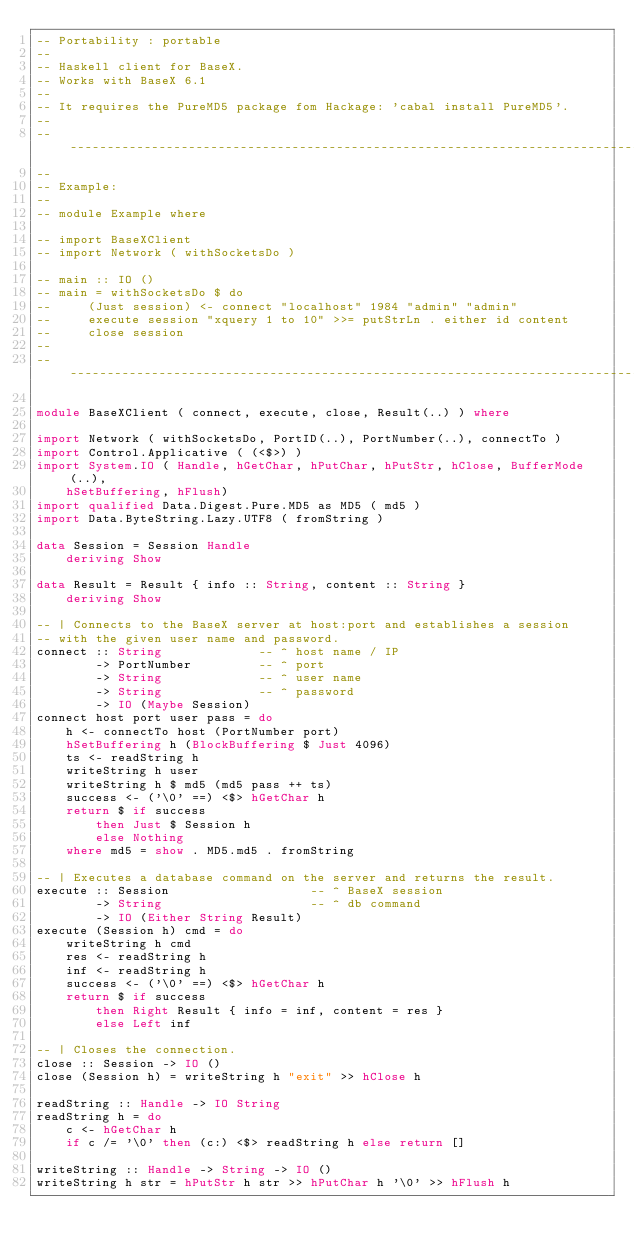Convert code to text. <code><loc_0><loc_0><loc_500><loc_500><_Haskell_>-- Portability : portable
--
-- Haskell client for BaseX.
-- Works with BaseX 6.1
--
-- It requires the PureMD5 package fom Hackage: 'cabal install PureMD5'.
--
-------------------------------------------------------------------------------
-- 
-- Example:
-- 
-- module Example where

-- import BaseXClient
-- import Network ( withSocketsDo )

-- main :: IO ()
-- main = withSocketsDo $ do
--     (Just session) <- connect "localhost" 1984 "admin" "admin"
--     execute session "xquery 1 to 10" >>= putStrLn . either id content
--     close session
-- 
-------------------------------------------------------------------------------

module BaseXClient ( connect, execute, close, Result(..) ) where

import Network ( withSocketsDo, PortID(..), PortNumber(..), connectTo )
import Control.Applicative ( (<$>) )
import System.IO ( Handle, hGetChar, hPutChar, hPutStr, hClose, BufferMode(..),
    hSetBuffering, hFlush)
import qualified Data.Digest.Pure.MD5 as MD5 ( md5 )
import Data.ByteString.Lazy.UTF8 ( fromString )

data Session = Session Handle
    deriving Show

data Result = Result { info :: String, content :: String }
    deriving Show    

-- | Connects to the BaseX server at host:port and establishes a session 
-- with the given user name and password.
connect :: String             -- ^ host name / IP
        -> PortNumber         -- ^ port
        -> String             -- ^ user name
        -> String             -- ^ password
        -> IO (Maybe Session)
connect host port user pass = do
    h <- connectTo host (PortNumber port)
    hSetBuffering h (BlockBuffering $ Just 4096)
    ts <- readString h
    writeString h user
    writeString h $ md5 (md5 pass ++ ts)
    success <- ('\0' ==) <$> hGetChar h
    return $ if success
        then Just $ Session h
        else Nothing
    where md5 = show . MD5.md5 . fromString

-- | Executes a database command on the server and returns the result.
execute :: Session                   -- ^ BaseX session
        -> String                    -- ^ db command
        -> IO (Either String Result)
execute (Session h) cmd = do
    writeString h cmd
    res <- readString h
    inf <- readString h
    success <- ('\0' ==) <$> hGetChar h
    return $ if success
        then Right Result { info = inf, content = res }
        else Left inf

-- | Closes the connection.
close :: Session -> IO ()
close (Session h) = writeString h "exit" >> hClose h

readString :: Handle -> IO String
readString h = do
    c <- hGetChar h
    if c /= '\0' then (c:) <$> readString h else return []

writeString :: Handle -> String -> IO ()
writeString h str = hPutStr h str >> hPutChar h '\0' >> hFlush h
</code> 